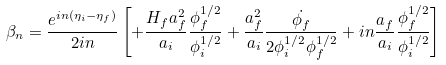Convert formula to latex. <formula><loc_0><loc_0><loc_500><loc_500>\beta _ { n } = \frac { e ^ { i n ( \eta _ { i } - \eta _ { f } ) } } { 2 i n } \left [ + \frac { H _ { f } a _ { f } ^ { 2 } } { a _ { i } } \frac { \phi _ { f } ^ { 1 / 2 } } { \phi _ { i } ^ { 1 / 2 } } + \frac { a _ { f } ^ { 2 } } { a _ { i } } \frac { \dot { \phi _ { f } } } { 2 \phi _ { i } ^ { 1 / 2 } \phi _ { f } ^ { 1 / 2 } } + i n \frac { a _ { f } } { a _ { i } } \frac { \phi _ { f } ^ { 1 / 2 } } { \phi _ { i } ^ { 1 / 2 } } \right ]</formula> 